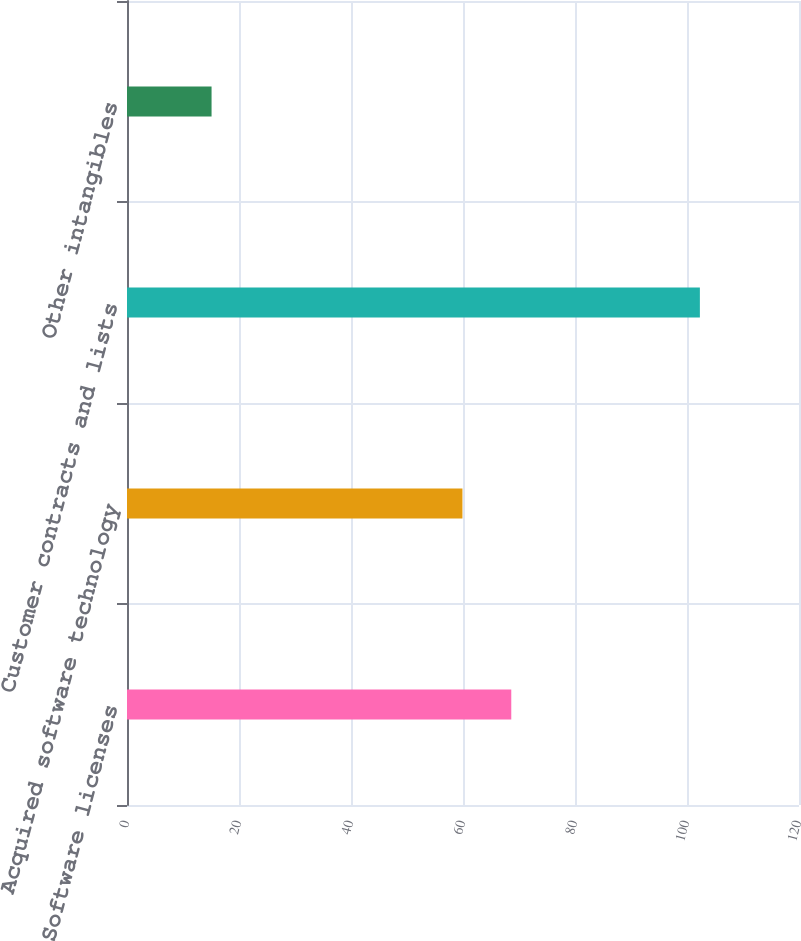Convert chart. <chart><loc_0><loc_0><loc_500><loc_500><bar_chart><fcel>Software licenses<fcel>Acquired software technology<fcel>Customer contracts and lists<fcel>Other intangibles<nl><fcel>68.62<fcel>59.9<fcel>102.3<fcel>15.1<nl></chart> 